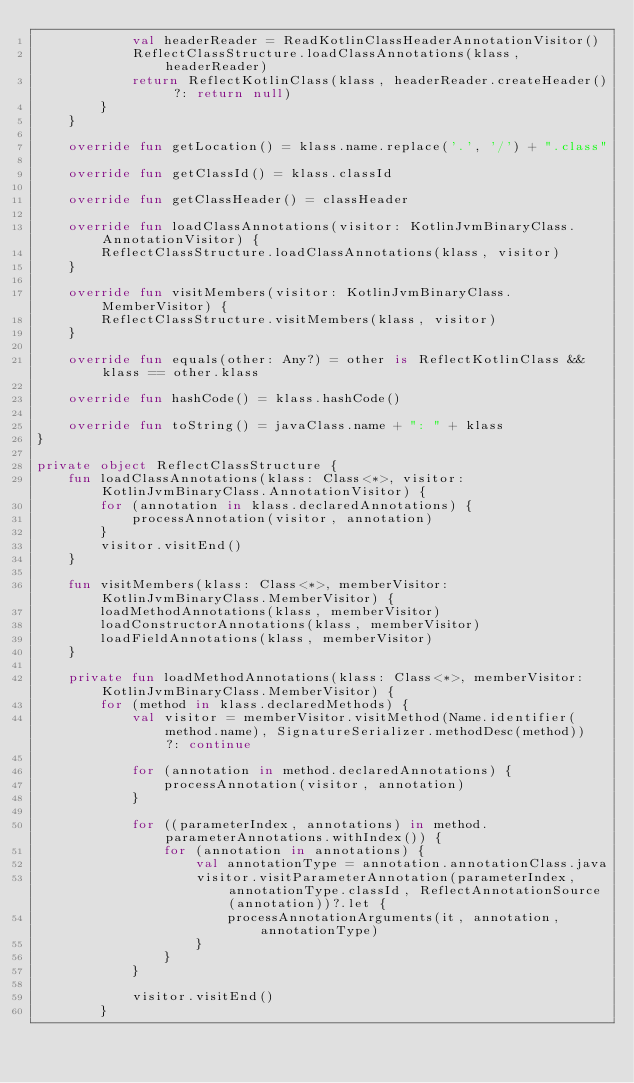<code> <loc_0><loc_0><loc_500><loc_500><_Kotlin_>            val headerReader = ReadKotlinClassHeaderAnnotationVisitor()
            ReflectClassStructure.loadClassAnnotations(klass, headerReader)
            return ReflectKotlinClass(klass, headerReader.createHeader() ?: return null)
        }
    }

    override fun getLocation() = klass.name.replace('.', '/') + ".class"

    override fun getClassId() = klass.classId

    override fun getClassHeader() = classHeader

    override fun loadClassAnnotations(visitor: KotlinJvmBinaryClass.AnnotationVisitor) {
        ReflectClassStructure.loadClassAnnotations(klass, visitor)
    }

    override fun visitMembers(visitor: KotlinJvmBinaryClass.MemberVisitor) {
        ReflectClassStructure.visitMembers(klass, visitor)
    }

    override fun equals(other: Any?) = other is ReflectKotlinClass && klass == other.klass

    override fun hashCode() = klass.hashCode()

    override fun toString() = javaClass.name + ": " + klass
}

private object ReflectClassStructure {
    fun loadClassAnnotations(klass: Class<*>, visitor: KotlinJvmBinaryClass.AnnotationVisitor) {
        for (annotation in klass.declaredAnnotations) {
            processAnnotation(visitor, annotation)
        }
        visitor.visitEnd()
    }

    fun visitMembers(klass: Class<*>, memberVisitor: KotlinJvmBinaryClass.MemberVisitor) {
        loadMethodAnnotations(klass, memberVisitor)
        loadConstructorAnnotations(klass, memberVisitor)
        loadFieldAnnotations(klass, memberVisitor)
    }

    private fun loadMethodAnnotations(klass: Class<*>, memberVisitor: KotlinJvmBinaryClass.MemberVisitor) {
        for (method in klass.declaredMethods) {
            val visitor = memberVisitor.visitMethod(Name.identifier(method.name), SignatureSerializer.methodDesc(method)) ?: continue

            for (annotation in method.declaredAnnotations) {
                processAnnotation(visitor, annotation)
            }

            for ((parameterIndex, annotations) in method.parameterAnnotations.withIndex()) {
                for (annotation in annotations) {
                    val annotationType = annotation.annotationClass.java
                    visitor.visitParameterAnnotation(parameterIndex, annotationType.classId, ReflectAnnotationSource(annotation))?.let {
                        processAnnotationArguments(it, annotation, annotationType)
                    }
                }
            }

            visitor.visitEnd()
        }</code> 